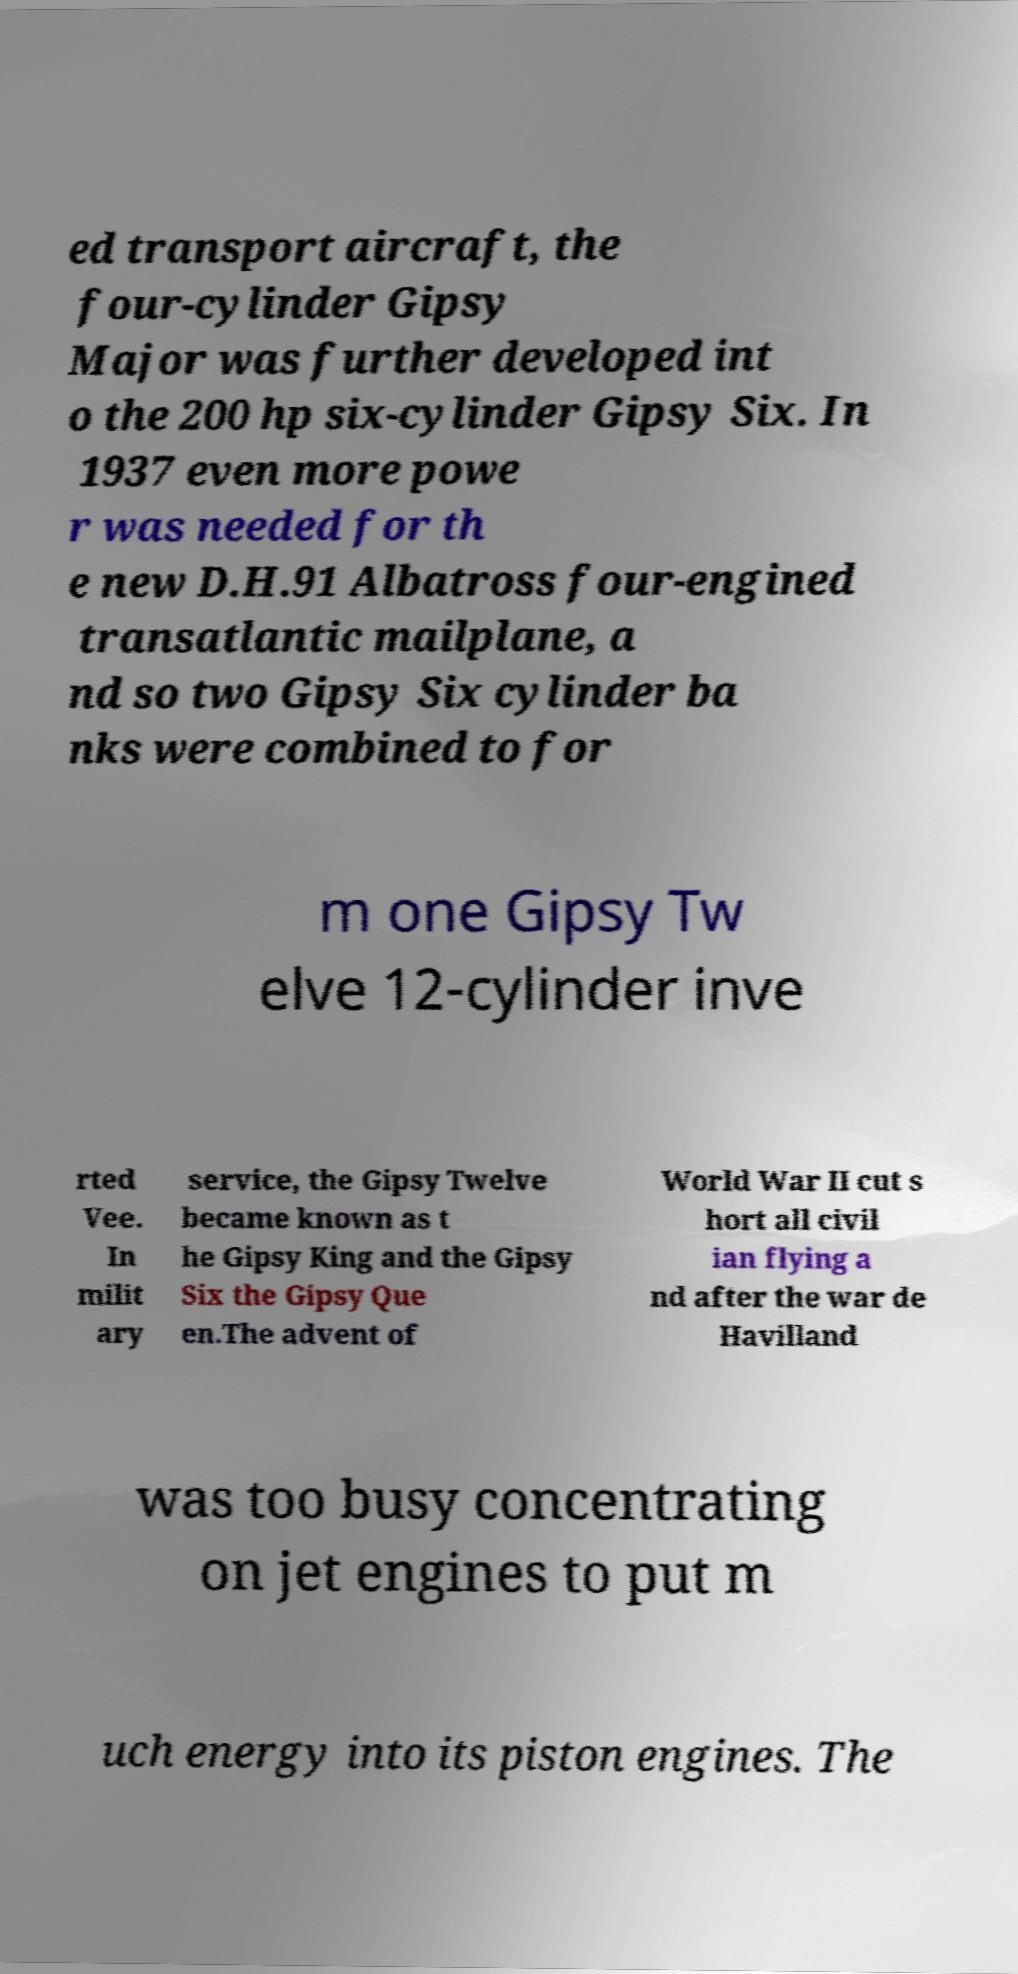Please read and relay the text visible in this image. What does it say? ed transport aircraft, the four-cylinder Gipsy Major was further developed int o the 200 hp six-cylinder Gipsy Six. In 1937 even more powe r was needed for th e new D.H.91 Albatross four-engined transatlantic mailplane, a nd so two Gipsy Six cylinder ba nks were combined to for m one Gipsy Tw elve 12-cylinder inve rted Vee. In milit ary service, the Gipsy Twelve became known as t he Gipsy King and the Gipsy Six the Gipsy Que en.The advent of World War II cut s hort all civil ian flying a nd after the war de Havilland was too busy concentrating on jet engines to put m uch energy into its piston engines. The 